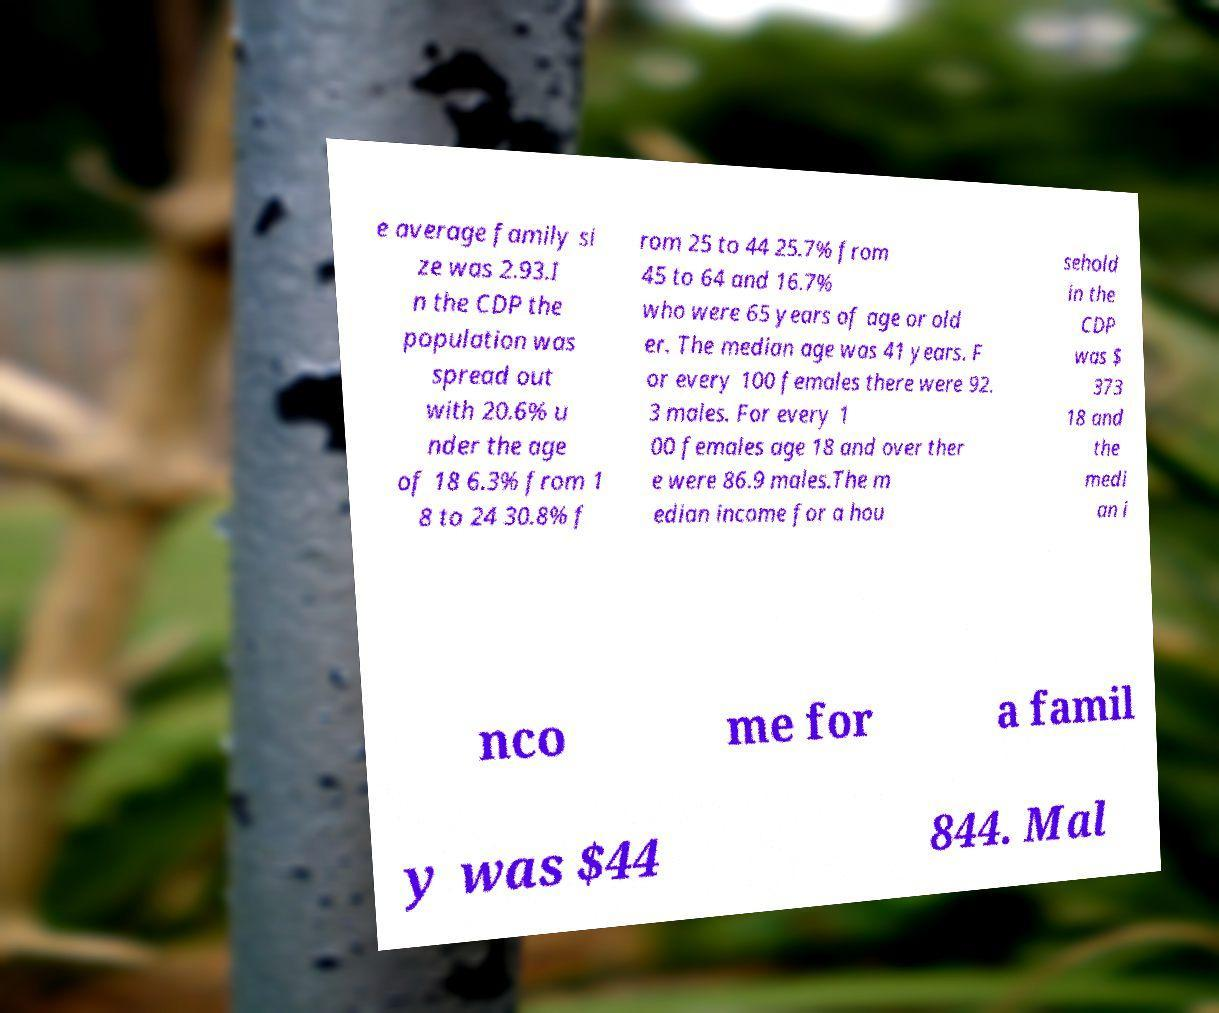What messages or text are displayed in this image? I need them in a readable, typed format. e average family si ze was 2.93.I n the CDP the population was spread out with 20.6% u nder the age of 18 6.3% from 1 8 to 24 30.8% f rom 25 to 44 25.7% from 45 to 64 and 16.7% who were 65 years of age or old er. The median age was 41 years. F or every 100 females there were 92. 3 males. For every 1 00 females age 18 and over ther e were 86.9 males.The m edian income for a hou sehold in the CDP was $ 373 18 and the medi an i nco me for a famil y was $44 844. Mal 